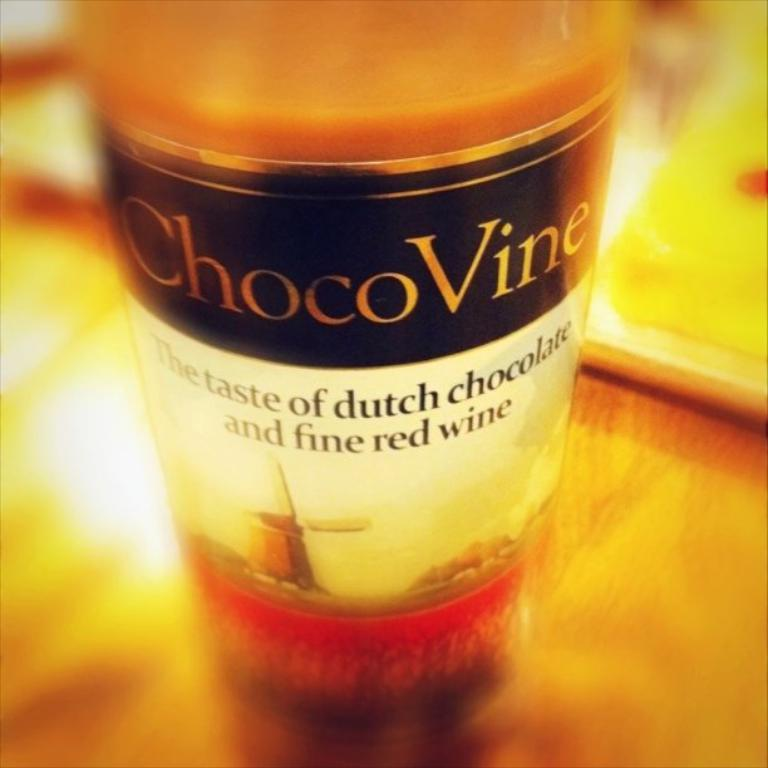<image>
Write a terse but informative summary of the picture. the word dutch is on the bottle of chocovine 